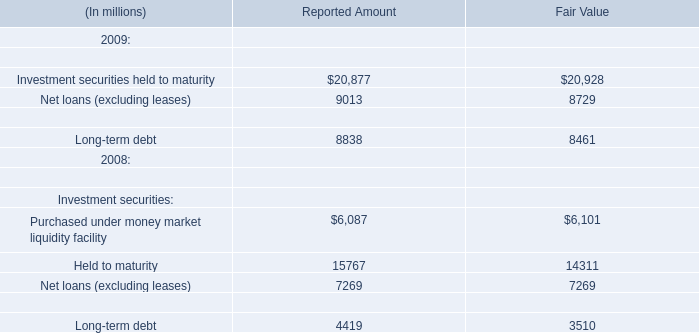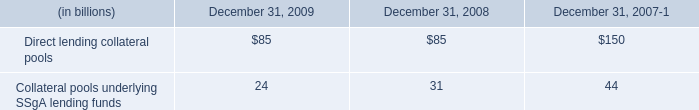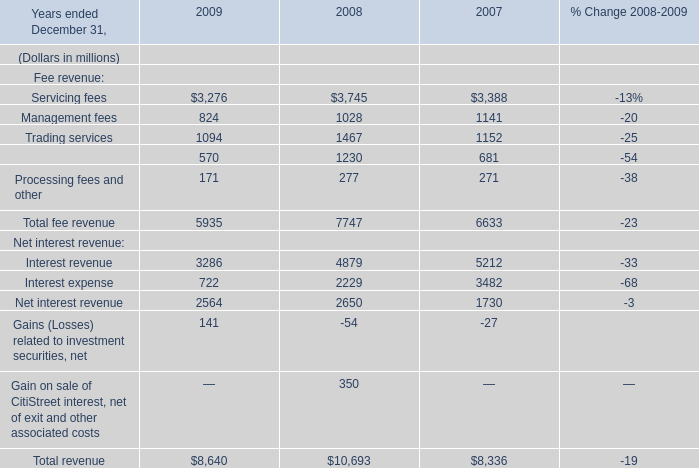what was the percent change in the aggregate net asset values of the collateral pools underlying ssga lending funds between 2008 and 2009? 
Computations: ((31 - 24) / 24)
Answer: 0.29167. 